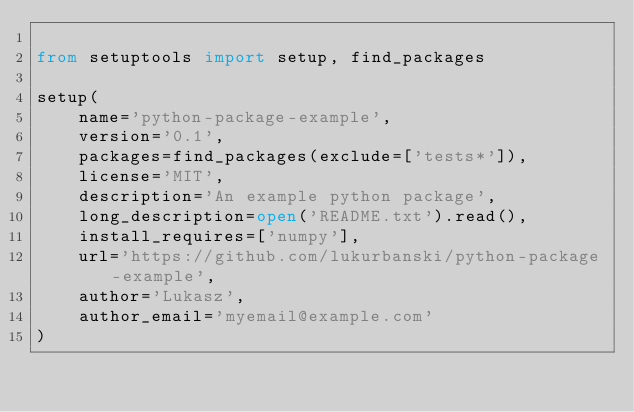Convert code to text. <code><loc_0><loc_0><loc_500><loc_500><_Python_>
from setuptools import setup, find_packages

setup(
    name='python-package-example',
    version='0.1',
    packages=find_packages(exclude=['tests*']),
    license='MIT',
    description='An example python package',
    long_description=open('README.txt').read(),
    install_requires=['numpy'],
    url='https://github.com/lukurbanski/python-package-example',
    author='Lukasz',
    author_email='myemail@example.com'
)

</code> 